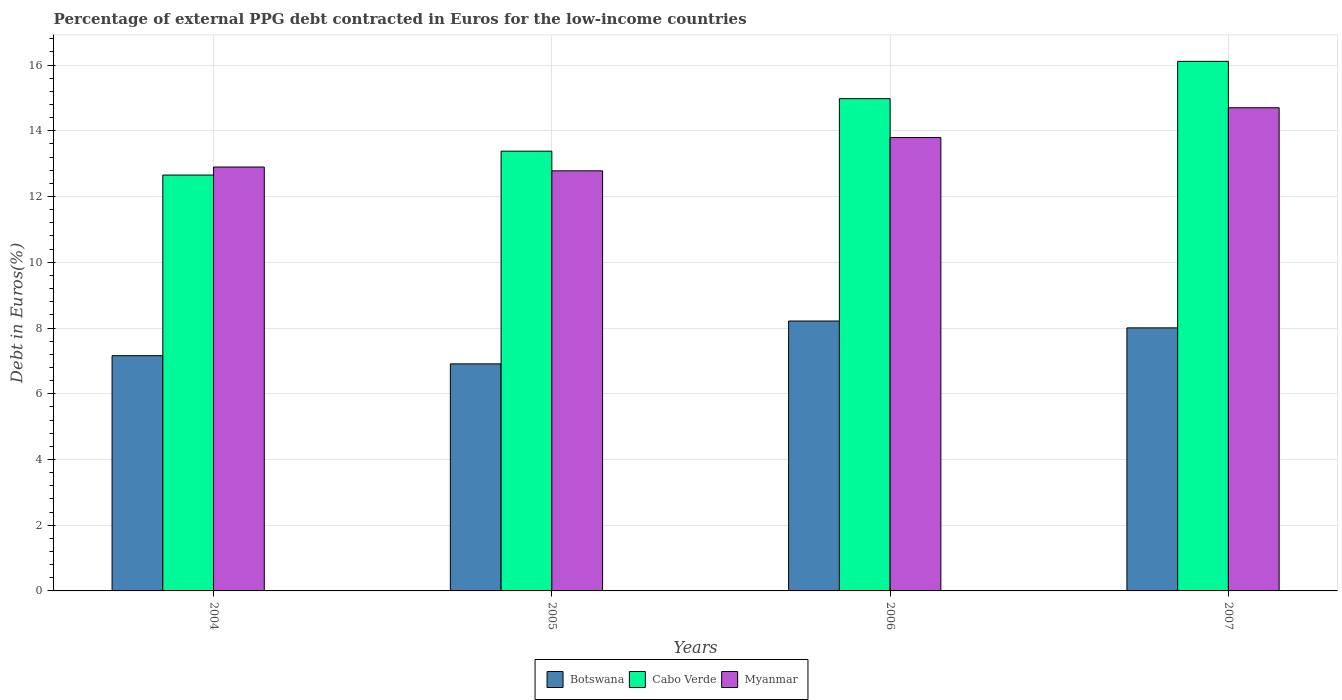How many different coloured bars are there?
Your response must be concise. 3. How many groups of bars are there?
Keep it short and to the point. 4. Are the number of bars per tick equal to the number of legend labels?
Your answer should be compact. Yes. How many bars are there on the 4th tick from the left?
Provide a succinct answer. 3. How many bars are there on the 2nd tick from the right?
Provide a short and direct response. 3. In how many cases, is the number of bars for a given year not equal to the number of legend labels?
Make the answer very short. 0. What is the percentage of external PPG debt contracted in Euros in Botswana in 2005?
Your response must be concise. 6.91. Across all years, what is the maximum percentage of external PPG debt contracted in Euros in Myanmar?
Make the answer very short. 14.7. Across all years, what is the minimum percentage of external PPG debt contracted in Euros in Botswana?
Your response must be concise. 6.91. In which year was the percentage of external PPG debt contracted in Euros in Cabo Verde maximum?
Your response must be concise. 2007. What is the total percentage of external PPG debt contracted in Euros in Myanmar in the graph?
Your response must be concise. 54.18. What is the difference between the percentage of external PPG debt contracted in Euros in Cabo Verde in 2006 and that in 2007?
Your answer should be compact. -1.14. What is the difference between the percentage of external PPG debt contracted in Euros in Botswana in 2005 and the percentage of external PPG debt contracted in Euros in Cabo Verde in 2004?
Give a very brief answer. -5.75. What is the average percentage of external PPG debt contracted in Euros in Botswana per year?
Ensure brevity in your answer.  7.57. In the year 2007, what is the difference between the percentage of external PPG debt contracted in Euros in Cabo Verde and percentage of external PPG debt contracted in Euros in Myanmar?
Your answer should be compact. 1.41. In how many years, is the percentage of external PPG debt contracted in Euros in Botswana greater than 11.6 %?
Your answer should be very brief. 0. What is the ratio of the percentage of external PPG debt contracted in Euros in Botswana in 2004 to that in 2006?
Make the answer very short. 0.87. What is the difference between the highest and the second highest percentage of external PPG debt contracted in Euros in Botswana?
Ensure brevity in your answer.  0.21. What is the difference between the highest and the lowest percentage of external PPG debt contracted in Euros in Cabo Verde?
Offer a terse response. 3.46. In how many years, is the percentage of external PPG debt contracted in Euros in Botswana greater than the average percentage of external PPG debt contracted in Euros in Botswana taken over all years?
Your answer should be compact. 2. Is the sum of the percentage of external PPG debt contracted in Euros in Botswana in 2005 and 2006 greater than the maximum percentage of external PPG debt contracted in Euros in Myanmar across all years?
Provide a succinct answer. Yes. What does the 1st bar from the left in 2007 represents?
Your answer should be very brief. Botswana. What does the 1st bar from the right in 2006 represents?
Provide a short and direct response. Myanmar. How many bars are there?
Provide a succinct answer. 12. Are all the bars in the graph horizontal?
Your answer should be compact. No. How many years are there in the graph?
Make the answer very short. 4. Are the values on the major ticks of Y-axis written in scientific E-notation?
Your answer should be compact. No. Does the graph contain grids?
Your answer should be very brief. Yes. How many legend labels are there?
Keep it short and to the point. 3. How are the legend labels stacked?
Ensure brevity in your answer.  Horizontal. What is the title of the graph?
Ensure brevity in your answer.  Percentage of external PPG debt contracted in Euros for the low-income countries. Does "Iraq" appear as one of the legend labels in the graph?
Give a very brief answer. No. What is the label or title of the Y-axis?
Give a very brief answer. Debt in Euros(%). What is the Debt in Euros(%) in Botswana in 2004?
Your response must be concise. 7.16. What is the Debt in Euros(%) in Cabo Verde in 2004?
Offer a very short reply. 12.65. What is the Debt in Euros(%) of Myanmar in 2004?
Offer a terse response. 12.9. What is the Debt in Euros(%) in Botswana in 2005?
Give a very brief answer. 6.91. What is the Debt in Euros(%) of Cabo Verde in 2005?
Make the answer very short. 13.38. What is the Debt in Euros(%) in Myanmar in 2005?
Keep it short and to the point. 12.78. What is the Debt in Euros(%) in Botswana in 2006?
Give a very brief answer. 8.21. What is the Debt in Euros(%) of Cabo Verde in 2006?
Your answer should be compact. 14.98. What is the Debt in Euros(%) in Myanmar in 2006?
Offer a very short reply. 13.8. What is the Debt in Euros(%) of Botswana in 2007?
Give a very brief answer. 8. What is the Debt in Euros(%) in Cabo Verde in 2007?
Your answer should be very brief. 16.11. What is the Debt in Euros(%) of Myanmar in 2007?
Your answer should be very brief. 14.7. Across all years, what is the maximum Debt in Euros(%) in Botswana?
Make the answer very short. 8.21. Across all years, what is the maximum Debt in Euros(%) of Cabo Verde?
Ensure brevity in your answer.  16.11. Across all years, what is the maximum Debt in Euros(%) in Myanmar?
Ensure brevity in your answer.  14.7. Across all years, what is the minimum Debt in Euros(%) in Botswana?
Your answer should be very brief. 6.91. Across all years, what is the minimum Debt in Euros(%) of Cabo Verde?
Your response must be concise. 12.65. Across all years, what is the minimum Debt in Euros(%) in Myanmar?
Your answer should be very brief. 12.78. What is the total Debt in Euros(%) of Botswana in the graph?
Provide a short and direct response. 30.28. What is the total Debt in Euros(%) in Cabo Verde in the graph?
Your answer should be very brief. 57.13. What is the total Debt in Euros(%) of Myanmar in the graph?
Keep it short and to the point. 54.18. What is the difference between the Debt in Euros(%) in Botswana in 2004 and that in 2005?
Your answer should be very brief. 0.25. What is the difference between the Debt in Euros(%) in Cabo Verde in 2004 and that in 2005?
Ensure brevity in your answer.  -0.73. What is the difference between the Debt in Euros(%) in Myanmar in 2004 and that in 2005?
Provide a short and direct response. 0.12. What is the difference between the Debt in Euros(%) in Botswana in 2004 and that in 2006?
Ensure brevity in your answer.  -1.05. What is the difference between the Debt in Euros(%) of Cabo Verde in 2004 and that in 2006?
Your answer should be very brief. -2.32. What is the difference between the Debt in Euros(%) of Myanmar in 2004 and that in 2006?
Your answer should be compact. -0.9. What is the difference between the Debt in Euros(%) in Botswana in 2004 and that in 2007?
Give a very brief answer. -0.85. What is the difference between the Debt in Euros(%) of Cabo Verde in 2004 and that in 2007?
Provide a succinct answer. -3.46. What is the difference between the Debt in Euros(%) in Myanmar in 2004 and that in 2007?
Provide a succinct answer. -1.8. What is the difference between the Debt in Euros(%) in Botswana in 2005 and that in 2006?
Ensure brevity in your answer.  -1.3. What is the difference between the Debt in Euros(%) of Cabo Verde in 2005 and that in 2006?
Provide a short and direct response. -1.6. What is the difference between the Debt in Euros(%) in Myanmar in 2005 and that in 2006?
Make the answer very short. -1.01. What is the difference between the Debt in Euros(%) of Botswana in 2005 and that in 2007?
Offer a very short reply. -1.1. What is the difference between the Debt in Euros(%) in Cabo Verde in 2005 and that in 2007?
Your response must be concise. -2.73. What is the difference between the Debt in Euros(%) in Myanmar in 2005 and that in 2007?
Provide a succinct answer. -1.92. What is the difference between the Debt in Euros(%) of Botswana in 2006 and that in 2007?
Provide a succinct answer. 0.21. What is the difference between the Debt in Euros(%) in Cabo Verde in 2006 and that in 2007?
Offer a terse response. -1.14. What is the difference between the Debt in Euros(%) in Myanmar in 2006 and that in 2007?
Give a very brief answer. -0.91. What is the difference between the Debt in Euros(%) of Botswana in 2004 and the Debt in Euros(%) of Cabo Verde in 2005?
Offer a very short reply. -6.22. What is the difference between the Debt in Euros(%) of Botswana in 2004 and the Debt in Euros(%) of Myanmar in 2005?
Offer a terse response. -5.62. What is the difference between the Debt in Euros(%) of Cabo Verde in 2004 and the Debt in Euros(%) of Myanmar in 2005?
Provide a succinct answer. -0.13. What is the difference between the Debt in Euros(%) in Botswana in 2004 and the Debt in Euros(%) in Cabo Verde in 2006?
Make the answer very short. -7.82. What is the difference between the Debt in Euros(%) of Botswana in 2004 and the Debt in Euros(%) of Myanmar in 2006?
Provide a short and direct response. -6.64. What is the difference between the Debt in Euros(%) in Cabo Verde in 2004 and the Debt in Euros(%) in Myanmar in 2006?
Keep it short and to the point. -1.14. What is the difference between the Debt in Euros(%) in Botswana in 2004 and the Debt in Euros(%) in Cabo Verde in 2007?
Give a very brief answer. -8.96. What is the difference between the Debt in Euros(%) of Botswana in 2004 and the Debt in Euros(%) of Myanmar in 2007?
Provide a succinct answer. -7.54. What is the difference between the Debt in Euros(%) in Cabo Verde in 2004 and the Debt in Euros(%) in Myanmar in 2007?
Your answer should be very brief. -2.05. What is the difference between the Debt in Euros(%) of Botswana in 2005 and the Debt in Euros(%) of Cabo Verde in 2006?
Offer a terse response. -8.07. What is the difference between the Debt in Euros(%) of Botswana in 2005 and the Debt in Euros(%) of Myanmar in 2006?
Offer a very short reply. -6.89. What is the difference between the Debt in Euros(%) of Cabo Verde in 2005 and the Debt in Euros(%) of Myanmar in 2006?
Ensure brevity in your answer.  -0.41. What is the difference between the Debt in Euros(%) in Botswana in 2005 and the Debt in Euros(%) in Cabo Verde in 2007?
Ensure brevity in your answer.  -9.21. What is the difference between the Debt in Euros(%) in Botswana in 2005 and the Debt in Euros(%) in Myanmar in 2007?
Your answer should be compact. -7.79. What is the difference between the Debt in Euros(%) in Cabo Verde in 2005 and the Debt in Euros(%) in Myanmar in 2007?
Provide a succinct answer. -1.32. What is the difference between the Debt in Euros(%) in Botswana in 2006 and the Debt in Euros(%) in Cabo Verde in 2007?
Offer a terse response. -7.9. What is the difference between the Debt in Euros(%) in Botswana in 2006 and the Debt in Euros(%) in Myanmar in 2007?
Keep it short and to the point. -6.49. What is the difference between the Debt in Euros(%) in Cabo Verde in 2006 and the Debt in Euros(%) in Myanmar in 2007?
Provide a succinct answer. 0.28. What is the average Debt in Euros(%) in Botswana per year?
Make the answer very short. 7.57. What is the average Debt in Euros(%) in Cabo Verde per year?
Provide a short and direct response. 14.28. What is the average Debt in Euros(%) of Myanmar per year?
Keep it short and to the point. 13.54. In the year 2004, what is the difference between the Debt in Euros(%) in Botswana and Debt in Euros(%) in Cabo Verde?
Provide a short and direct response. -5.5. In the year 2004, what is the difference between the Debt in Euros(%) in Botswana and Debt in Euros(%) in Myanmar?
Ensure brevity in your answer.  -5.74. In the year 2004, what is the difference between the Debt in Euros(%) of Cabo Verde and Debt in Euros(%) of Myanmar?
Your answer should be very brief. -0.24. In the year 2005, what is the difference between the Debt in Euros(%) of Botswana and Debt in Euros(%) of Cabo Verde?
Ensure brevity in your answer.  -6.47. In the year 2005, what is the difference between the Debt in Euros(%) in Botswana and Debt in Euros(%) in Myanmar?
Keep it short and to the point. -5.87. In the year 2005, what is the difference between the Debt in Euros(%) of Cabo Verde and Debt in Euros(%) of Myanmar?
Make the answer very short. 0.6. In the year 2006, what is the difference between the Debt in Euros(%) of Botswana and Debt in Euros(%) of Cabo Verde?
Offer a terse response. -6.77. In the year 2006, what is the difference between the Debt in Euros(%) in Botswana and Debt in Euros(%) in Myanmar?
Ensure brevity in your answer.  -5.58. In the year 2006, what is the difference between the Debt in Euros(%) in Cabo Verde and Debt in Euros(%) in Myanmar?
Your answer should be very brief. 1.18. In the year 2007, what is the difference between the Debt in Euros(%) of Botswana and Debt in Euros(%) of Cabo Verde?
Make the answer very short. -8.11. In the year 2007, what is the difference between the Debt in Euros(%) of Botswana and Debt in Euros(%) of Myanmar?
Give a very brief answer. -6.7. In the year 2007, what is the difference between the Debt in Euros(%) in Cabo Verde and Debt in Euros(%) in Myanmar?
Keep it short and to the point. 1.41. What is the ratio of the Debt in Euros(%) in Botswana in 2004 to that in 2005?
Provide a succinct answer. 1.04. What is the ratio of the Debt in Euros(%) in Cabo Verde in 2004 to that in 2005?
Offer a terse response. 0.95. What is the ratio of the Debt in Euros(%) of Myanmar in 2004 to that in 2005?
Provide a succinct answer. 1.01. What is the ratio of the Debt in Euros(%) in Botswana in 2004 to that in 2006?
Ensure brevity in your answer.  0.87. What is the ratio of the Debt in Euros(%) in Cabo Verde in 2004 to that in 2006?
Ensure brevity in your answer.  0.84. What is the ratio of the Debt in Euros(%) in Myanmar in 2004 to that in 2006?
Ensure brevity in your answer.  0.94. What is the ratio of the Debt in Euros(%) in Botswana in 2004 to that in 2007?
Your answer should be compact. 0.89. What is the ratio of the Debt in Euros(%) in Cabo Verde in 2004 to that in 2007?
Ensure brevity in your answer.  0.79. What is the ratio of the Debt in Euros(%) of Myanmar in 2004 to that in 2007?
Ensure brevity in your answer.  0.88. What is the ratio of the Debt in Euros(%) in Botswana in 2005 to that in 2006?
Keep it short and to the point. 0.84. What is the ratio of the Debt in Euros(%) of Cabo Verde in 2005 to that in 2006?
Your response must be concise. 0.89. What is the ratio of the Debt in Euros(%) of Myanmar in 2005 to that in 2006?
Ensure brevity in your answer.  0.93. What is the ratio of the Debt in Euros(%) of Botswana in 2005 to that in 2007?
Ensure brevity in your answer.  0.86. What is the ratio of the Debt in Euros(%) of Cabo Verde in 2005 to that in 2007?
Provide a short and direct response. 0.83. What is the ratio of the Debt in Euros(%) in Myanmar in 2005 to that in 2007?
Your answer should be very brief. 0.87. What is the ratio of the Debt in Euros(%) of Cabo Verde in 2006 to that in 2007?
Provide a short and direct response. 0.93. What is the ratio of the Debt in Euros(%) of Myanmar in 2006 to that in 2007?
Provide a succinct answer. 0.94. What is the difference between the highest and the second highest Debt in Euros(%) of Botswana?
Offer a very short reply. 0.21. What is the difference between the highest and the second highest Debt in Euros(%) in Cabo Verde?
Ensure brevity in your answer.  1.14. What is the difference between the highest and the second highest Debt in Euros(%) in Myanmar?
Keep it short and to the point. 0.91. What is the difference between the highest and the lowest Debt in Euros(%) in Botswana?
Offer a terse response. 1.3. What is the difference between the highest and the lowest Debt in Euros(%) in Cabo Verde?
Offer a terse response. 3.46. What is the difference between the highest and the lowest Debt in Euros(%) in Myanmar?
Ensure brevity in your answer.  1.92. 